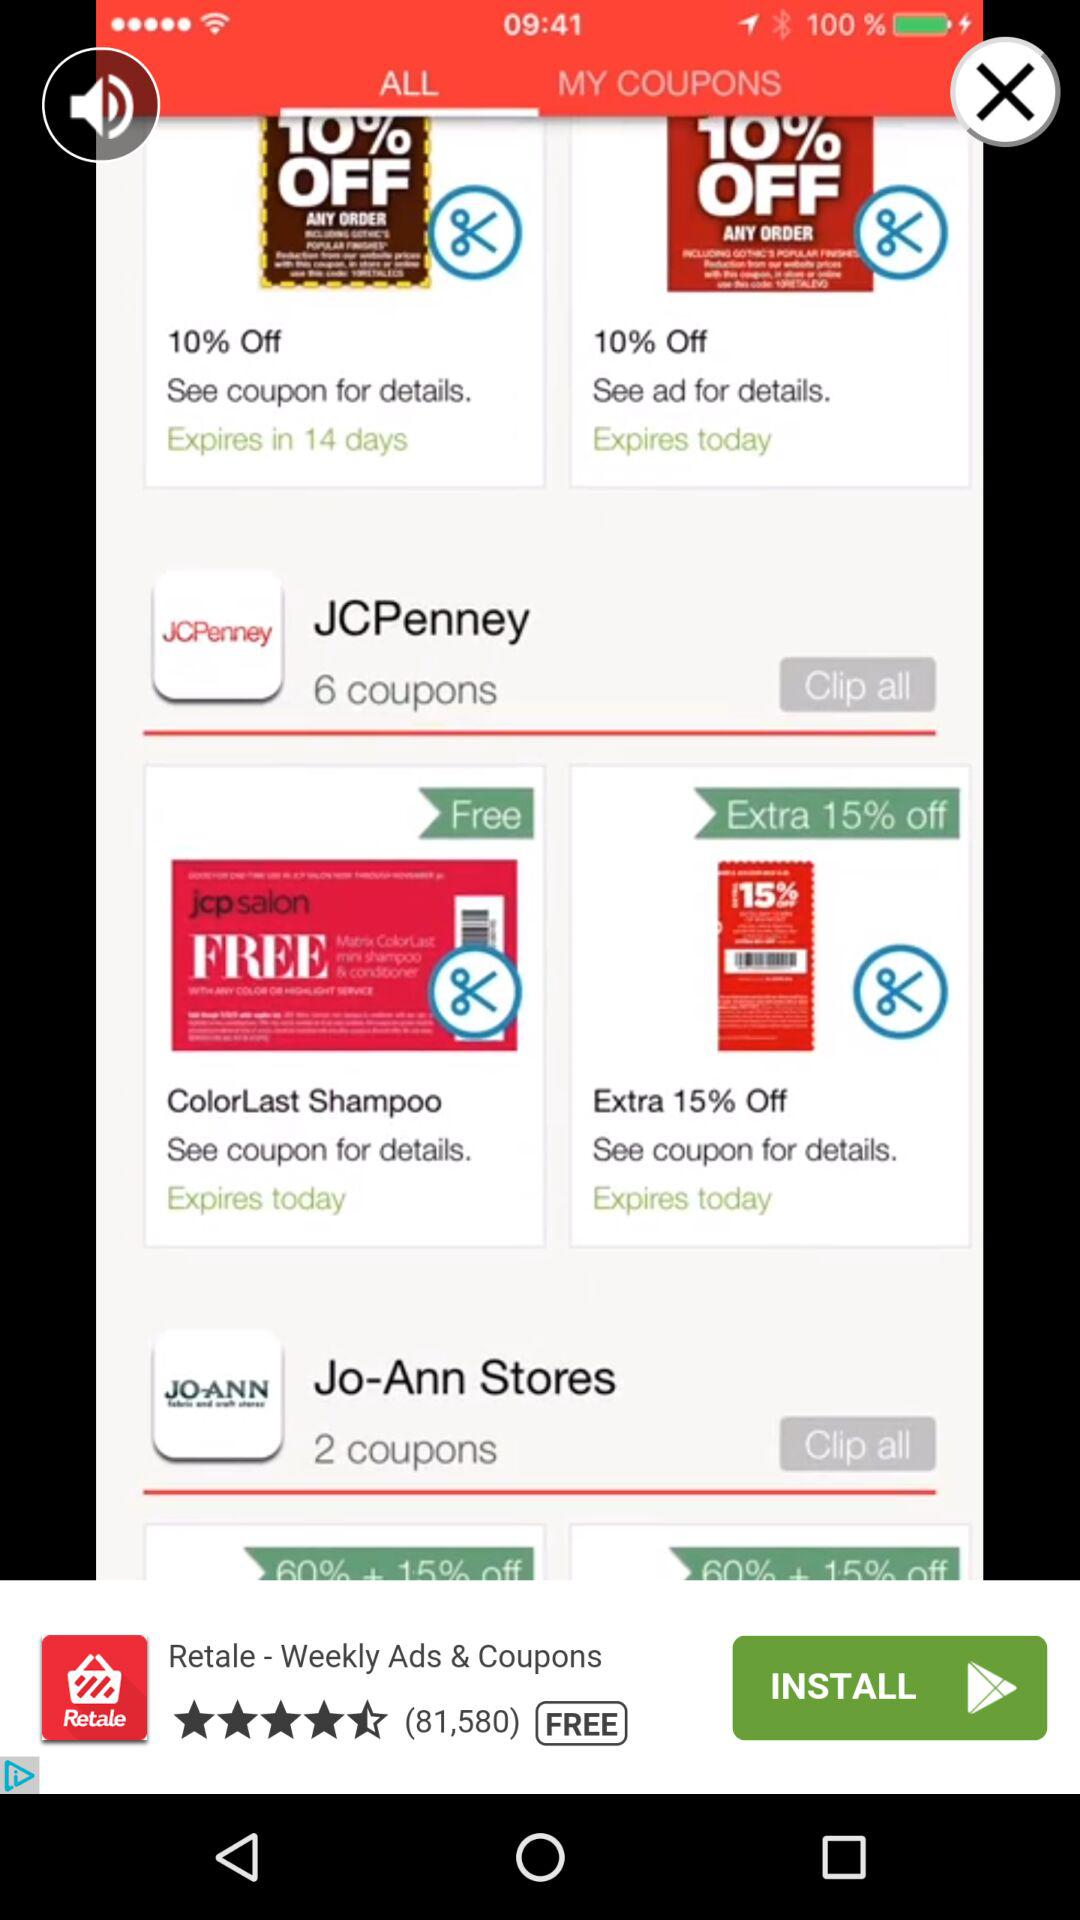Which tab is selected? The selected tab is "ALL". 